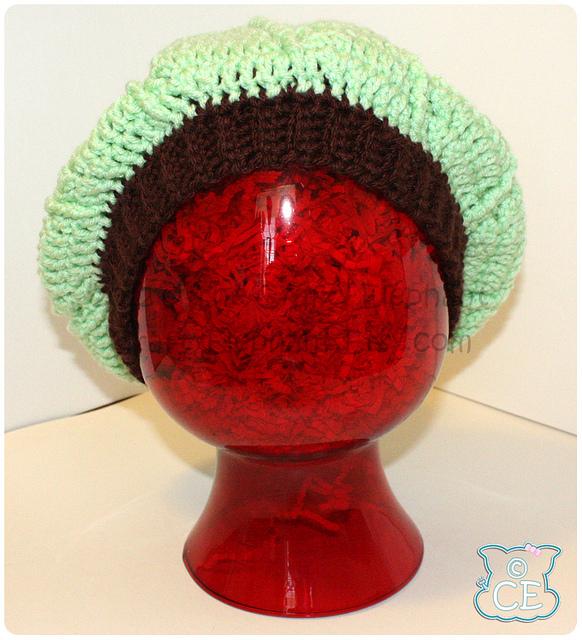What color is the hat?
Give a very brief answer. Green and brown. What colors are the hat?
Write a very short answer. Green. What letters are at the bottom right of the picture?
Short answer required. Ce. What does this resemble?
Give a very brief answer. Head. 